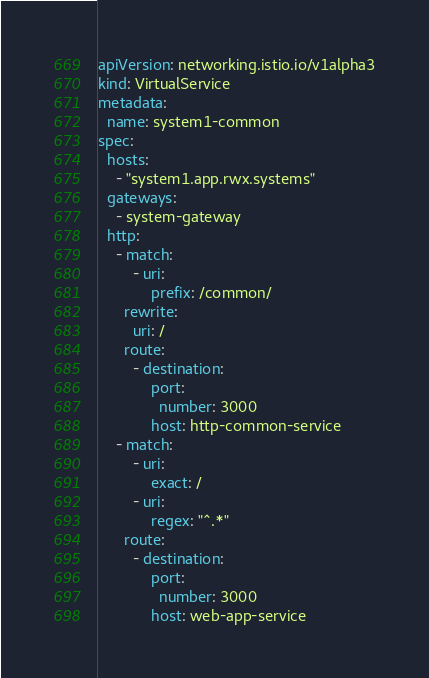Convert code to text. <code><loc_0><loc_0><loc_500><loc_500><_YAML_>apiVersion: networking.istio.io/v1alpha3
kind: VirtualService
metadata:
  name: system1-common
spec:
  hosts:
    - "system1.app.rwx.systems"
  gateways:
    - system-gateway
  http:
    - match:
        - uri:
            prefix: /common/
      rewrite:
        uri: /
      route:
        - destination:
            port:
              number: 3000
            host: http-common-service
    - match:
        - uri:
            exact: /
        - uri:
            regex: "^.*"
      route:
        - destination:
            port:
              number: 3000
            host: web-app-service
</code> 